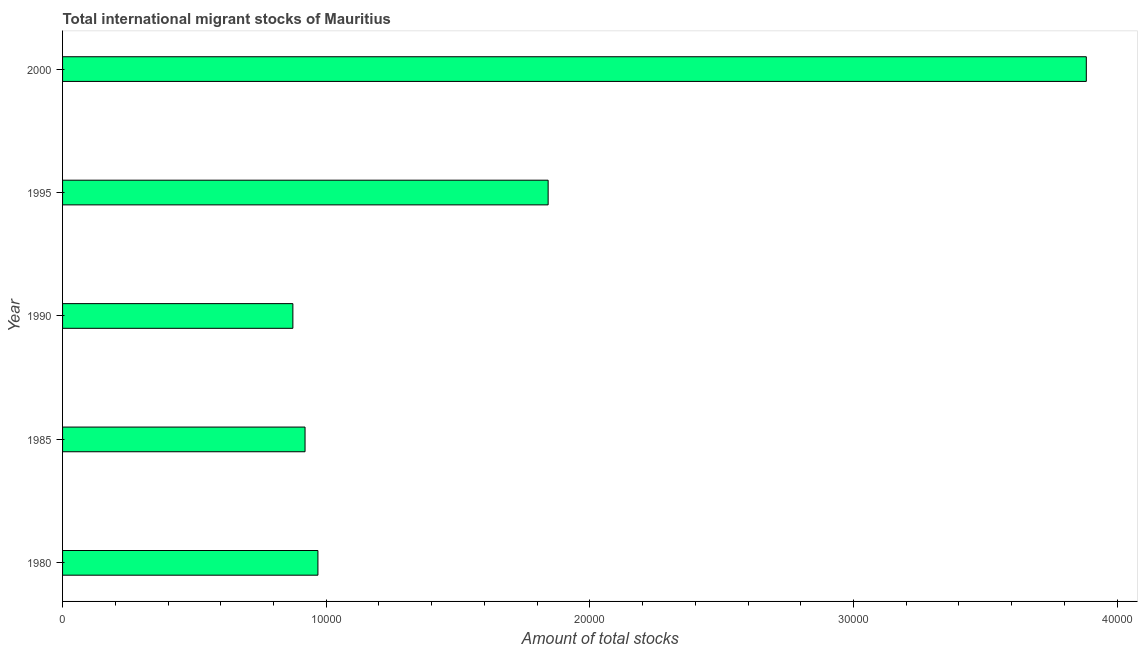What is the title of the graph?
Offer a terse response. Total international migrant stocks of Mauritius. What is the label or title of the X-axis?
Provide a short and direct response. Amount of total stocks. What is the label or title of the Y-axis?
Your answer should be compact. Year. What is the total number of international migrant stock in 2000?
Ensure brevity in your answer.  3.88e+04. Across all years, what is the maximum total number of international migrant stock?
Your answer should be very brief. 3.88e+04. Across all years, what is the minimum total number of international migrant stock?
Provide a succinct answer. 8736. In which year was the total number of international migrant stock maximum?
Ensure brevity in your answer.  2000. In which year was the total number of international migrant stock minimum?
Your response must be concise. 1990. What is the sum of the total number of international migrant stock?
Offer a very short reply. 8.49e+04. What is the difference between the total number of international migrant stock in 1985 and 1990?
Make the answer very short. 462. What is the average total number of international migrant stock per year?
Your response must be concise. 1.70e+04. What is the median total number of international migrant stock?
Provide a succinct answer. 9686. What is the ratio of the total number of international migrant stock in 1985 to that in 1990?
Ensure brevity in your answer.  1.05. Is the total number of international migrant stock in 1980 less than that in 2000?
Offer a terse response. Yes. Is the difference between the total number of international migrant stock in 1985 and 1995 greater than the difference between any two years?
Offer a very short reply. No. What is the difference between the highest and the second highest total number of international migrant stock?
Your response must be concise. 2.04e+04. Is the sum of the total number of international migrant stock in 1980 and 2000 greater than the maximum total number of international migrant stock across all years?
Your response must be concise. Yes. What is the difference between the highest and the lowest total number of international migrant stock?
Offer a very short reply. 3.01e+04. In how many years, is the total number of international migrant stock greater than the average total number of international migrant stock taken over all years?
Your response must be concise. 2. How many bars are there?
Your response must be concise. 5. Are all the bars in the graph horizontal?
Provide a succinct answer. Yes. How many years are there in the graph?
Ensure brevity in your answer.  5. What is the difference between two consecutive major ticks on the X-axis?
Give a very brief answer. 10000. What is the Amount of total stocks in 1980?
Provide a succinct answer. 9686. What is the Amount of total stocks of 1985?
Provide a succinct answer. 9198. What is the Amount of total stocks of 1990?
Offer a very short reply. 8736. What is the Amount of total stocks of 1995?
Keep it short and to the point. 1.84e+04. What is the Amount of total stocks of 2000?
Offer a terse response. 3.88e+04. What is the difference between the Amount of total stocks in 1980 and 1985?
Your response must be concise. 488. What is the difference between the Amount of total stocks in 1980 and 1990?
Your response must be concise. 950. What is the difference between the Amount of total stocks in 1980 and 1995?
Your answer should be very brief. -8733. What is the difference between the Amount of total stocks in 1980 and 2000?
Your answer should be very brief. -2.91e+04. What is the difference between the Amount of total stocks in 1985 and 1990?
Make the answer very short. 462. What is the difference between the Amount of total stocks in 1985 and 1995?
Keep it short and to the point. -9221. What is the difference between the Amount of total stocks in 1985 and 2000?
Ensure brevity in your answer.  -2.96e+04. What is the difference between the Amount of total stocks in 1990 and 1995?
Offer a terse response. -9683. What is the difference between the Amount of total stocks in 1990 and 2000?
Ensure brevity in your answer.  -3.01e+04. What is the difference between the Amount of total stocks in 1995 and 2000?
Provide a succinct answer. -2.04e+04. What is the ratio of the Amount of total stocks in 1980 to that in 1985?
Provide a succinct answer. 1.05. What is the ratio of the Amount of total stocks in 1980 to that in 1990?
Offer a very short reply. 1.11. What is the ratio of the Amount of total stocks in 1980 to that in 1995?
Provide a succinct answer. 0.53. What is the ratio of the Amount of total stocks in 1980 to that in 2000?
Provide a succinct answer. 0.25. What is the ratio of the Amount of total stocks in 1985 to that in 1990?
Your answer should be very brief. 1.05. What is the ratio of the Amount of total stocks in 1985 to that in 1995?
Keep it short and to the point. 0.5. What is the ratio of the Amount of total stocks in 1985 to that in 2000?
Your response must be concise. 0.24. What is the ratio of the Amount of total stocks in 1990 to that in 1995?
Your answer should be compact. 0.47. What is the ratio of the Amount of total stocks in 1990 to that in 2000?
Offer a terse response. 0.23. What is the ratio of the Amount of total stocks in 1995 to that in 2000?
Provide a short and direct response. 0.47. 